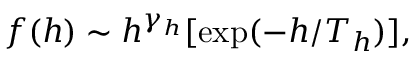<formula> <loc_0><loc_0><loc_500><loc_500>f ( h ) \sim h ^ { \gamma _ { h } } [ e x p ( - h / T _ { h } ) ] ,</formula> 